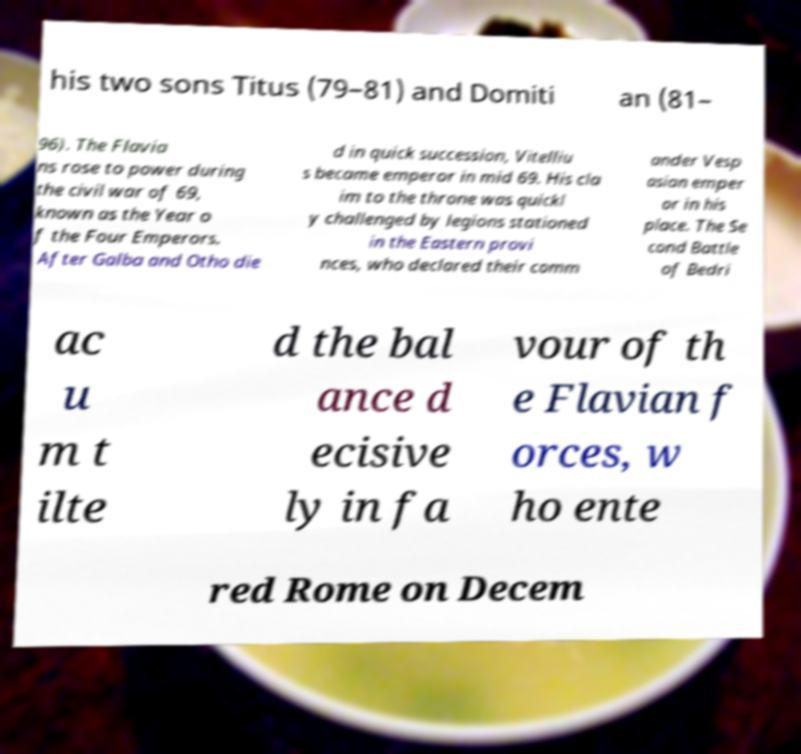I need the written content from this picture converted into text. Can you do that? his two sons Titus (79–81) and Domiti an (81– 96). The Flavia ns rose to power during the civil war of 69, known as the Year o f the Four Emperors. After Galba and Otho die d in quick succession, Vitelliu s became emperor in mid 69. His cla im to the throne was quickl y challenged by legions stationed in the Eastern provi nces, who declared their comm ander Vesp asian emper or in his place. The Se cond Battle of Bedri ac u m t ilte d the bal ance d ecisive ly in fa vour of th e Flavian f orces, w ho ente red Rome on Decem 